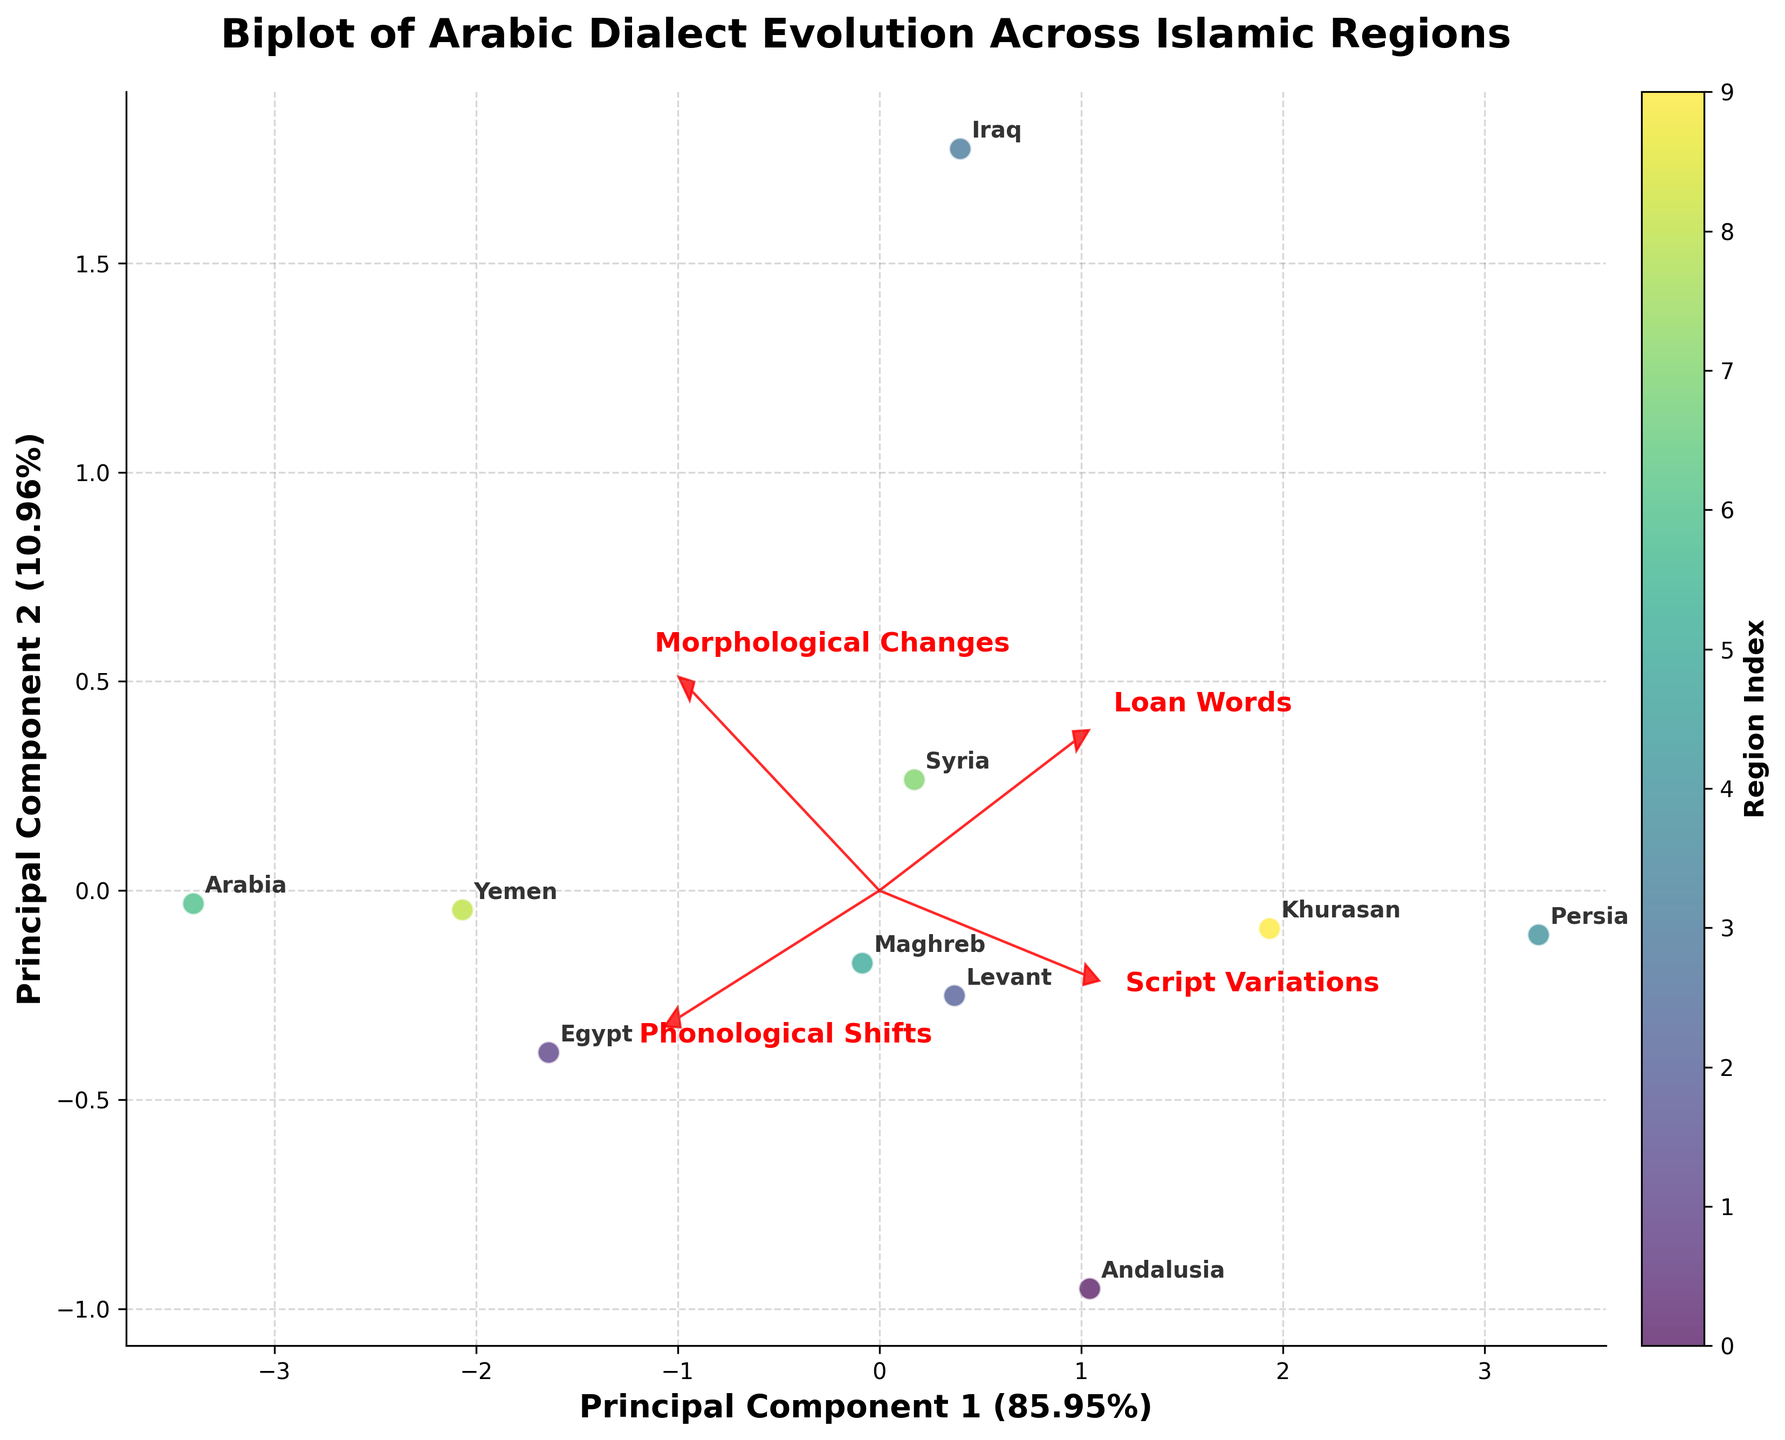What is the title of the figure? The title is the text at the top of the figure, indicating the subject of the plot. In this case, it describes the content of the biplot.
Answer: Biplot of Arabic Dialect Evolution Across Islamic Regions How many regions are represented in the plot? Count the number of unique data points or annotations on the plot that represent different regions.
Answer: 10 Which feature shows the highest variability along the first principal component? Look at the length of the loading vectors along the first principal component axis. The longest arrow indicates the feature with the highest variability.
Answer: Loan Words In which region do phonological shifts dominate compared to other changes? Identify the region by comparing the positioning relative to the phonological shifts loading vector. The region farthest along this vector represents the dominance.
Answer: Arabia Which two features are most closely related according to the biplot? Check the angles between the loading vectors. Smaller angles indicate a stronger correlation.
Answer: Morphological Changes and Phonological Shifts How does the region of Andalusia position itself in terms of loan words and script variations? Examine Andalusia's position relative to the loan words and script variations loading vectors. Its projection relative to these vectors will indicate its standing.
Answer: Moderate in both Is the explanation of variance greater for the first or the second principal component? Check the axis labels for the percentage of variance explained by each principal component. The higher percentage indicates greater variance.
Answer: First principal component Which two regions are most similar in terms of their linguistic features? Observe the proximity of the data points (regions) in the biplot. Closest points indicate similarity.
Answer: Levant and Syria Which region has the lowest loan words usage? Find the region closest to the origin in the direction opposite to the loan words loading vector.
Answer: Arabia What can you infer about the relationship between Egypt and morphological changes? Locate Egypt on the biplot and examine its position relative to the morphological changes loading vector. This will show its relation.
Answer: Strong relationship 